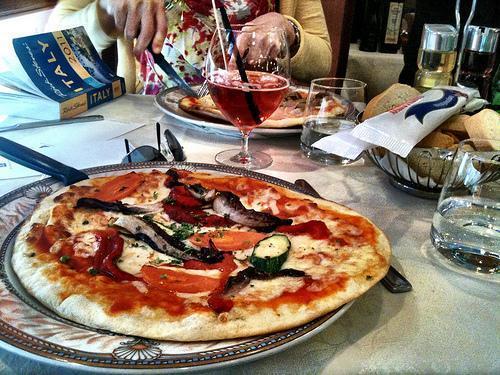How many shot glasses are on the table?
Give a very brief answer. 2. How many goblets are on the table?
Give a very brief answer. 1. How many people are pictured?
Give a very brief answer. 1. How many dinosaurs are in the picture?
Give a very brief answer. 0. How many glass cups have water in them?
Give a very brief answer. 2. 